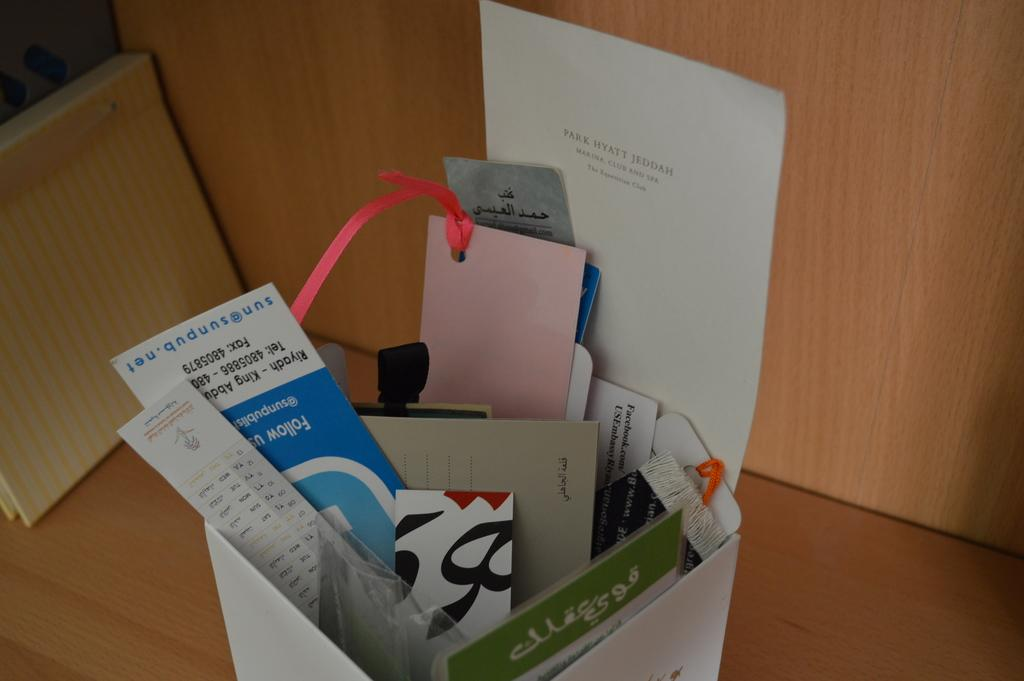<image>
Render a clear and concise summary of the photo. A white box holding various papers including something from the Park Hyatt Jeddah marina, club and spa. 